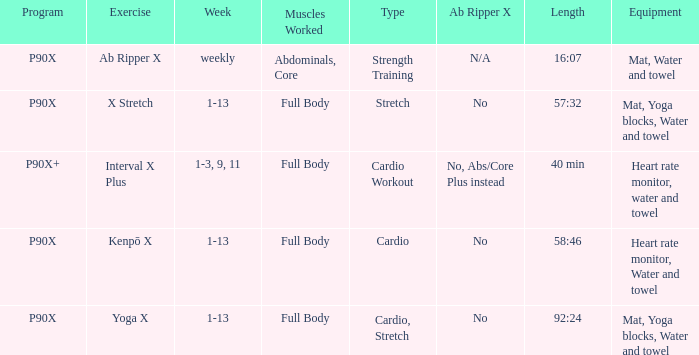What is the week when type is cardio workout? 1-3, 9, 11. 